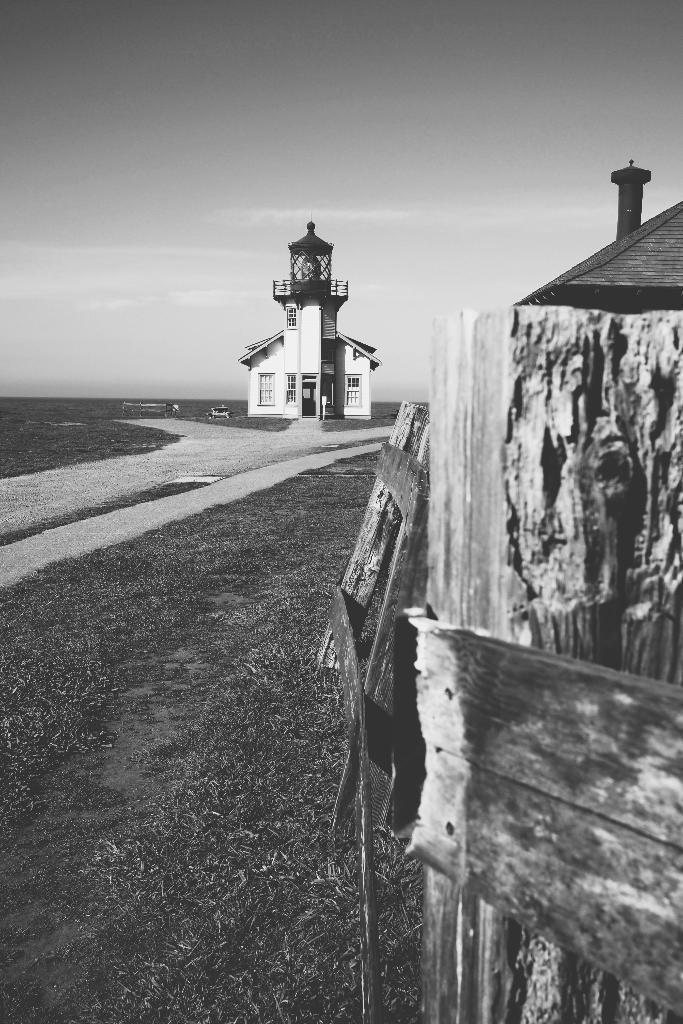In one or two sentences, can you explain what this image depicts? In this image I can see few buildings,windows and wooden fencing. The image is in black and white. 